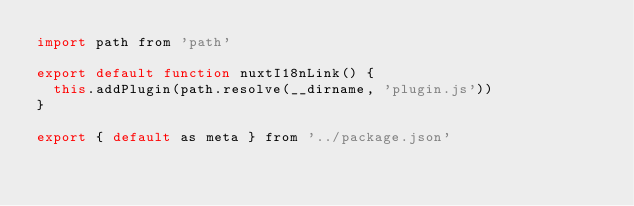<code> <loc_0><loc_0><loc_500><loc_500><_JavaScript_>import path from 'path'

export default function nuxtI18nLink() {
	this.addPlugin(path.resolve(__dirname, 'plugin.js'))
}

export { default as meta } from '../package.json'
</code> 